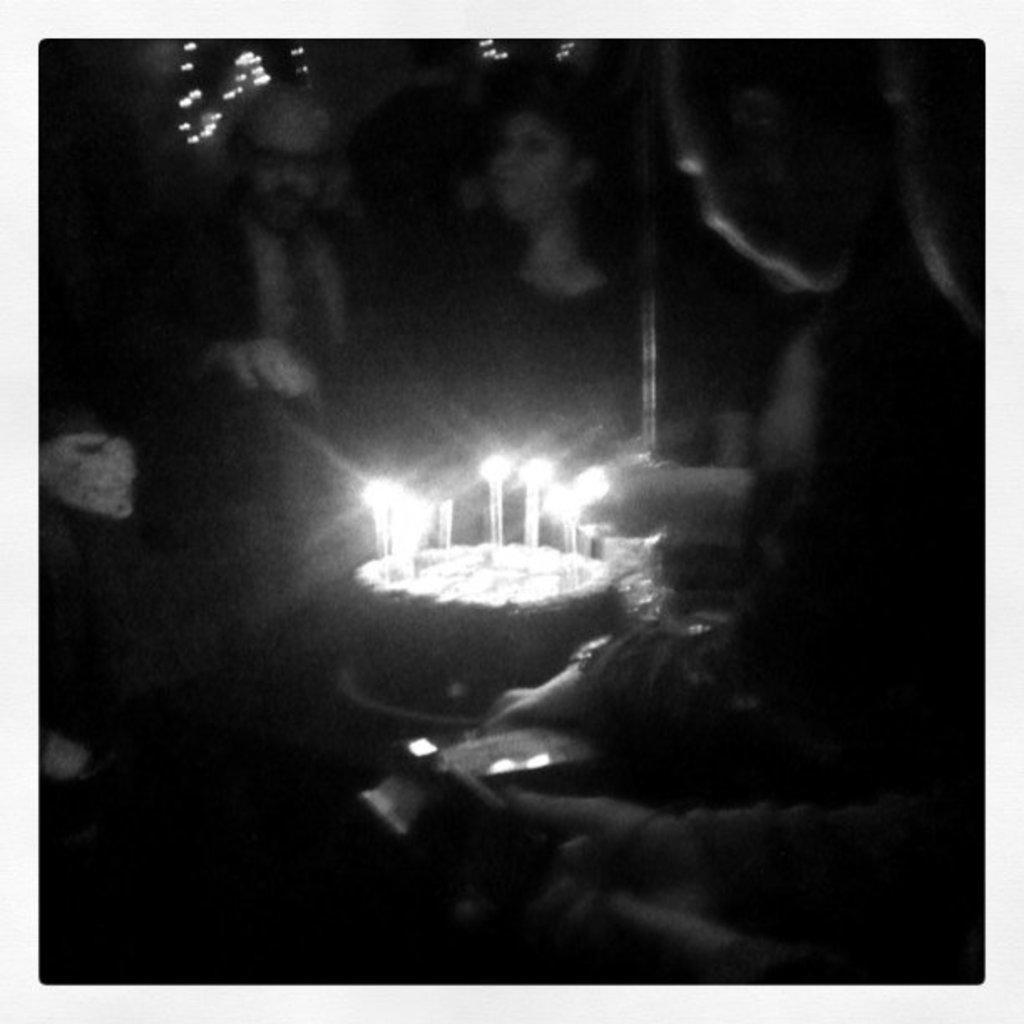What is the color scheme of the image? The image is black and white. What is the main subject in the image? There is a cake in the middle of the image. Where is the cake placed? The cake is placed on a table. What is on top of the cake? There are candles on the cake. Who is present in the image? There are people around the cake. How would you describe the lighting in the image? The people are in a dark environment. Can you see the moon in the image? No, the moon is not visible in the image. How do the people around the cake feel about the cake? The image does not provide information about the feelings of the people around the cake, so we cannot determine if they feel disgust or any other emotion. 